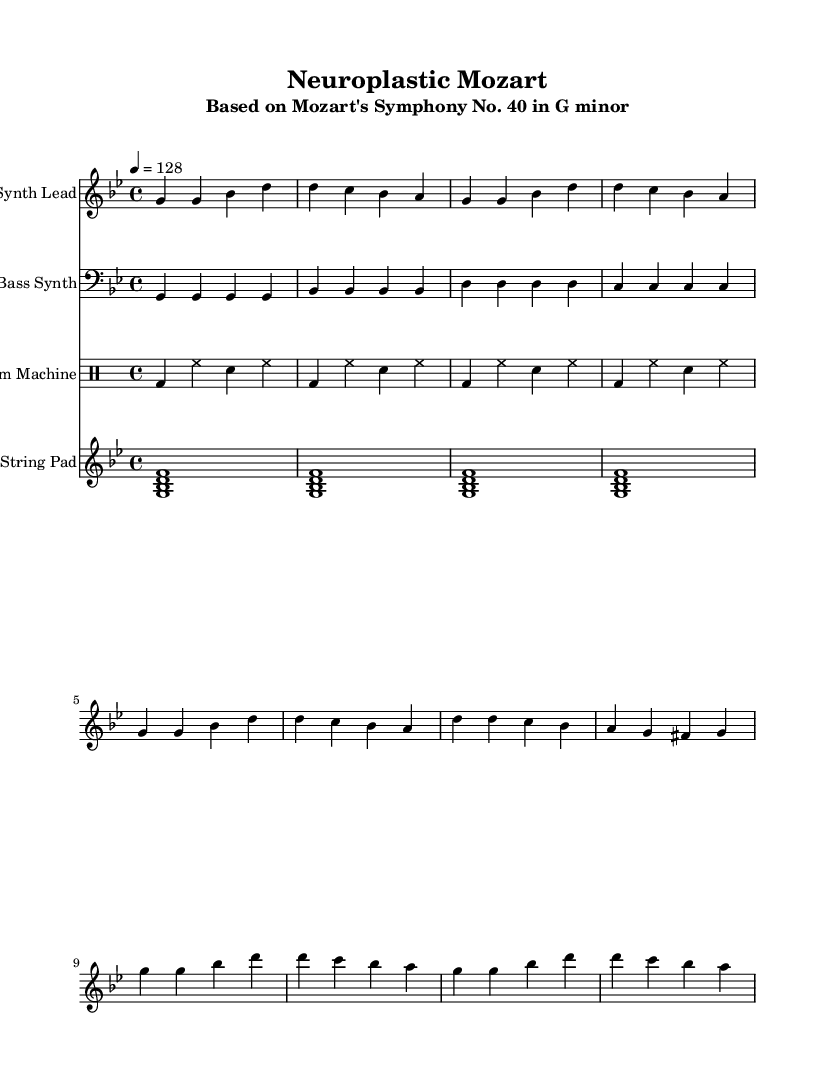What is the key signature of this music? The key signature is G minor, which has two flats (B flat and E flat). This can be identified by looking at the key signature at the beginning of the staff.
Answer: G minor What is the time signature of this piece? The time signature is 4/4, indicated at the beginning of the piece. This means there are four beats in each measure and the quarter note gets one beat.
Answer: 4/4 What is the tempo marking for this piece? The tempo marking is 128 beats per minute, as indicated in the tempo section. This gives the piece a lively, upbeat character suitable for dance music.
Answer: 128 How many measures are in the "Verse" section? The "Verse" section consists of four measures, as identified by counting the measures labeled as "Verse" in the score.
Answer: 4 Which instrument plays the bass line? The bass line is performed by the "Bass Synth," which is clearly labeled in the score. This part provides the foundation of the harmony and rhythm for the piece.
Answer: Bass Synth What is the primary rhythmic pattern used by the drum machine? The primary rhythmic pattern consists of bass drum on beats 1 and 3 and hi-hat on beats 2 and 4, creating a common dance rhythm. This can be seen in the "drumMachine" section of the score.
Answer: Bass and hi-hat What chord is primarily used in the string pad section? The string pad section primarily utilizes the G minor chord, indicated by the notes G, B flat, and D, which form the chord played by the string pad.
Answer: G minor 